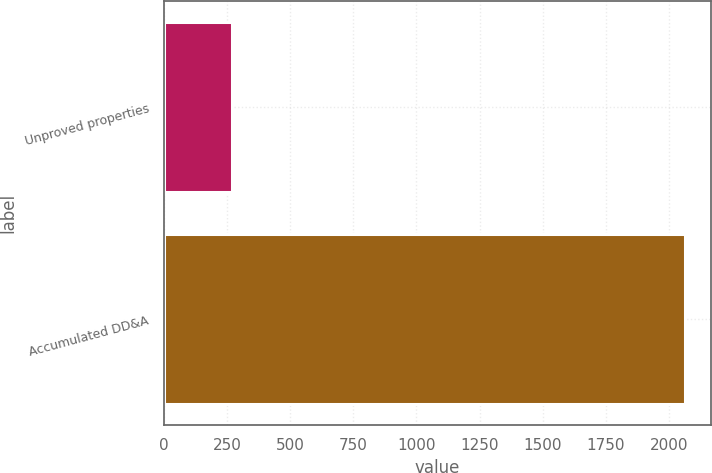Convert chart. <chart><loc_0><loc_0><loc_500><loc_500><bar_chart><fcel>Unproved properties<fcel>Accumulated DD&A<nl><fcel>270<fcel>2061<nl></chart> 